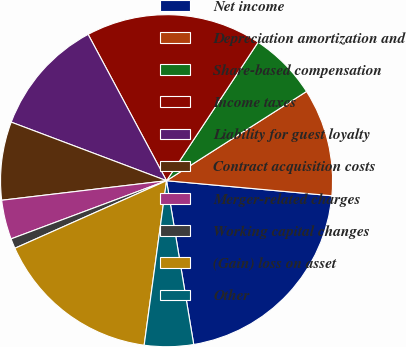Convert chart. <chart><loc_0><loc_0><loc_500><loc_500><pie_chart><fcel>Net income<fcel>Depreciation amortization and<fcel>Share-based compensation<fcel>Income taxes<fcel>Liability for guest loyalty<fcel>Contract acquisition costs<fcel>Merger-related charges<fcel>Working capital changes<fcel>(Gain) loss on asset<fcel>Other<nl><fcel>20.94%<fcel>10.48%<fcel>6.67%<fcel>17.13%<fcel>11.43%<fcel>7.62%<fcel>3.82%<fcel>0.97%<fcel>16.18%<fcel>4.77%<nl></chart> 